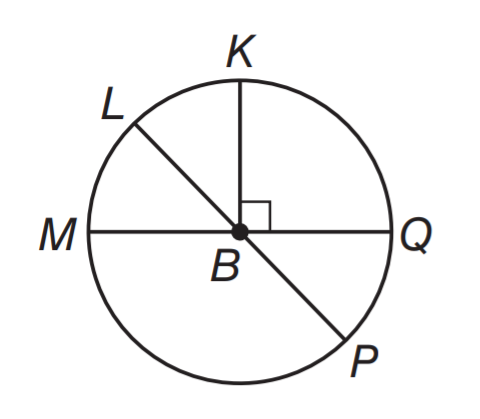Question: In \odot B, m \angle L B M = 3 x and m \angle L B Q = 4 x + 61. What is the measure of \angle P B Q?
Choices:
A. 17
B. 34
C. 51
D. 61
Answer with the letter. Answer: C Question: What is the area of the shaded region if r = 4.
Choices:
A. 16 - 16 \pi
B. 16 - 8 \pi
C. 64 - 16 \pi
D. 64 - 8 \pi
Answer with the letter. Answer: C 